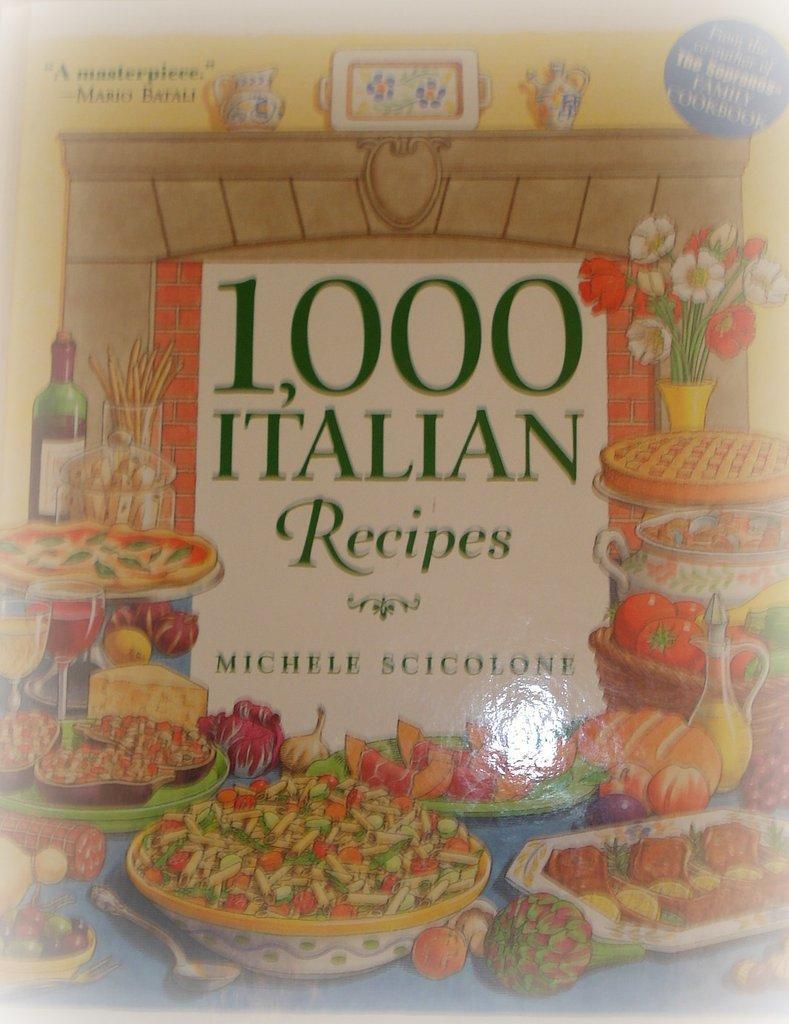Please provide a concise description of this image. This is a poster. In this image we can see food items on the plates on the platforms, wine bottles, jug with liquid in it and there are texts written on a boar and we can see jugs, tray on a platform at the wall and at the top we can see texts written on the image. 